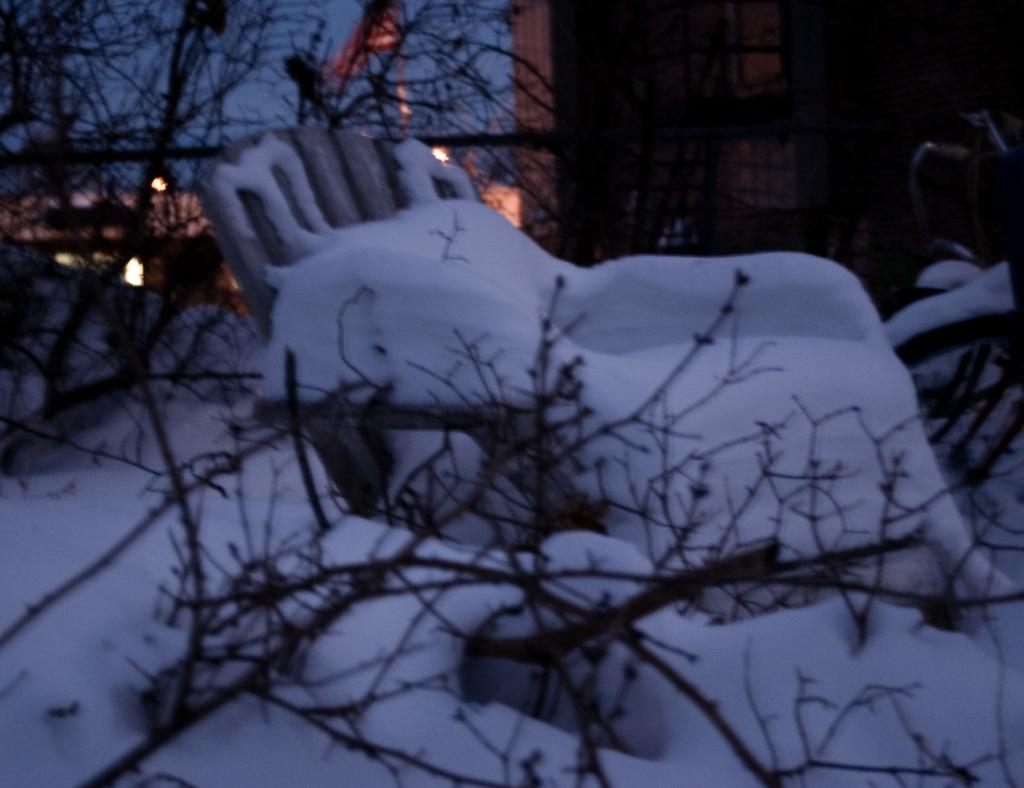What type of structures are present in the image? There are buildings in the image. Can you identify any specific objects in the image? Yes, there is a chair in the image. What type of natural elements are visible in the image? There are trees in the image. What is the weather like in the image? The weather is cold, as there is snow visible in the image. What type of illumination is present in the image? There are lights in the image. Where is the nearest hospital to the scene in the image? The provided facts do not mention any hospital, so it is not possible to determine the location of the nearest hospital. What type of transport is being used by the giants in the image? There are no giants present in the image, so it is not possible to determine what type of transport they might be using. 